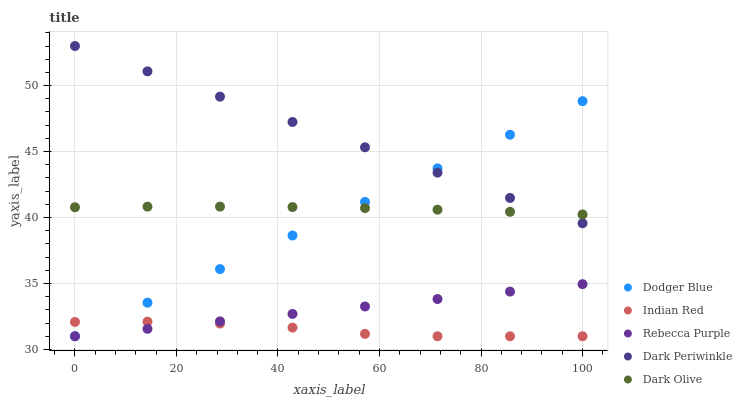Does Indian Red have the minimum area under the curve?
Answer yes or no. Yes. Does Dark Periwinkle have the maximum area under the curve?
Answer yes or no. Yes. Does Dodger Blue have the minimum area under the curve?
Answer yes or no. No. Does Dodger Blue have the maximum area under the curve?
Answer yes or no. No. Is Dark Periwinkle the smoothest?
Answer yes or no. Yes. Is Indian Red the roughest?
Answer yes or no. Yes. Is Dodger Blue the smoothest?
Answer yes or no. No. Is Dodger Blue the roughest?
Answer yes or no. No. Does Dodger Blue have the lowest value?
Answer yes or no. Yes. Does Dark Periwinkle have the lowest value?
Answer yes or no. No. Does Dark Periwinkle have the highest value?
Answer yes or no. Yes. Does Dodger Blue have the highest value?
Answer yes or no. No. Is Rebecca Purple less than Dark Periwinkle?
Answer yes or no. Yes. Is Dark Periwinkle greater than Indian Red?
Answer yes or no. Yes. Does Rebecca Purple intersect Dodger Blue?
Answer yes or no. Yes. Is Rebecca Purple less than Dodger Blue?
Answer yes or no. No. Is Rebecca Purple greater than Dodger Blue?
Answer yes or no. No. Does Rebecca Purple intersect Dark Periwinkle?
Answer yes or no. No. 